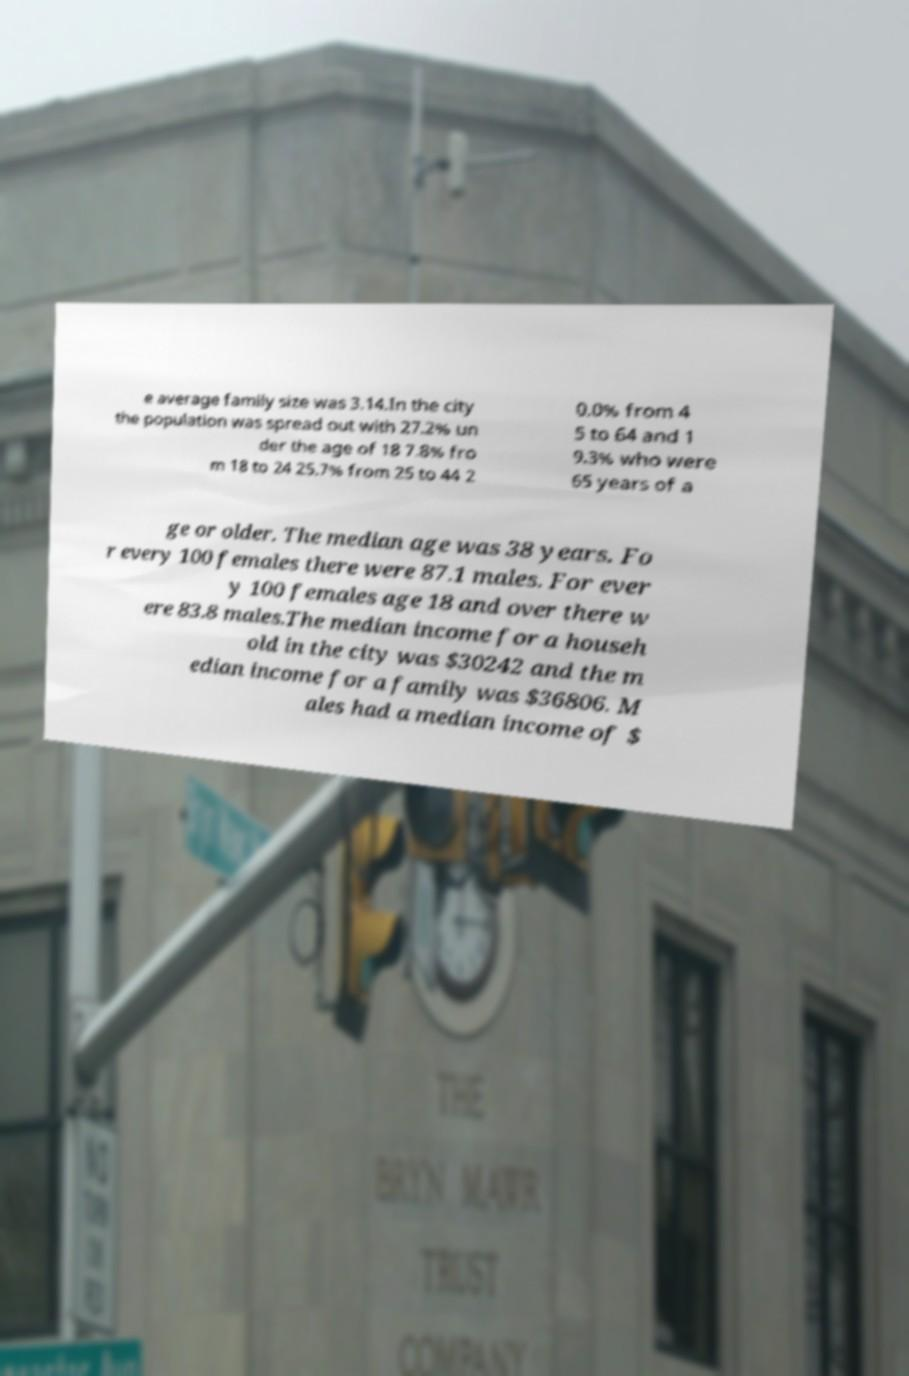There's text embedded in this image that I need extracted. Can you transcribe it verbatim? e average family size was 3.14.In the city the population was spread out with 27.2% un der the age of 18 7.8% fro m 18 to 24 25.7% from 25 to 44 2 0.0% from 4 5 to 64 and 1 9.3% who were 65 years of a ge or older. The median age was 38 years. Fo r every 100 females there were 87.1 males. For ever y 100 females age 18 and over there w ere 83.8 males.The median income for a househ old in the city was $30242 and the m edian income for a family was $36806. M ales had a median income of $ 